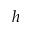Convert formula to latex. <formula><loc_0><loc_0><loc_500><loc_500>h</formula> 